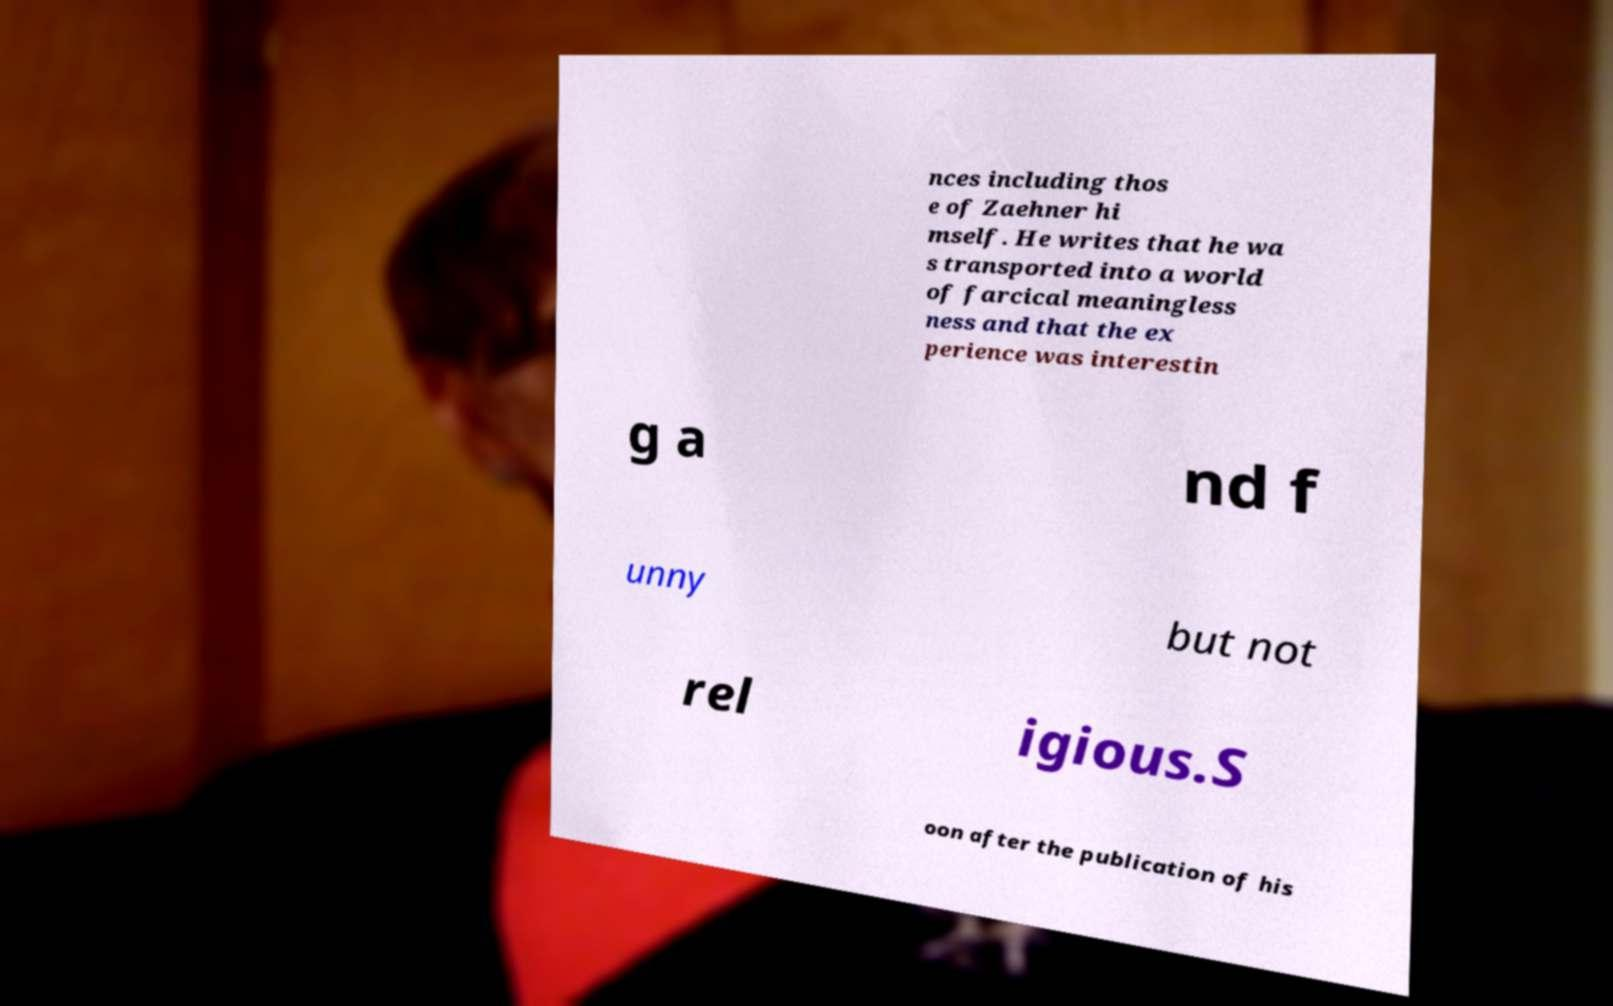Please read and relay the text visible in this image. What does it say? nces including thos e of Zaehner hi mself. He writes that he wa s transported into a world of farcical meaningless ness and that the ex perience was interestin g a nd f unny but not rel igious.S oon after the publication of his 